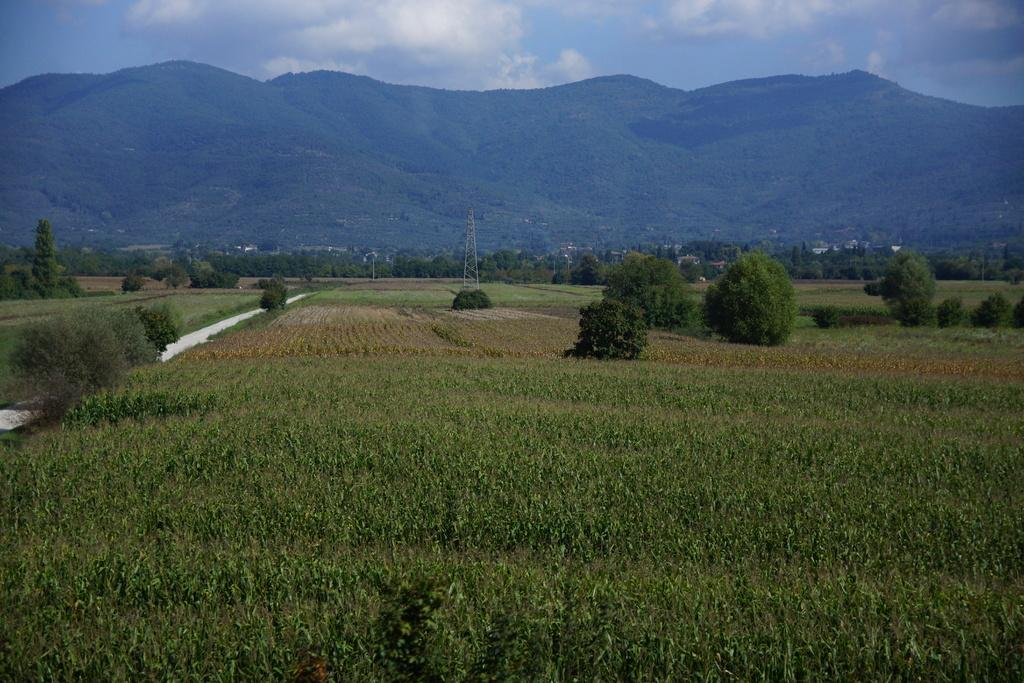What can be seen in the sky in the image? The sky with clouds is visible in the image. What type of natural features are present in the image? There are hills in the image. What man-made structures can be seen in the image? There are buildings and an electric tower present in the image. What type of land use is visible in the image? Agricultural farms are visible in the image. What type of vegetation is present in the image? Bushes are present in the image. What type of flame can be seen on the duck in the image? There is no duck or flame present in the image. What is the duck's desire in the image? There is no duck present in the image, so it is not possible to determine its desires. 